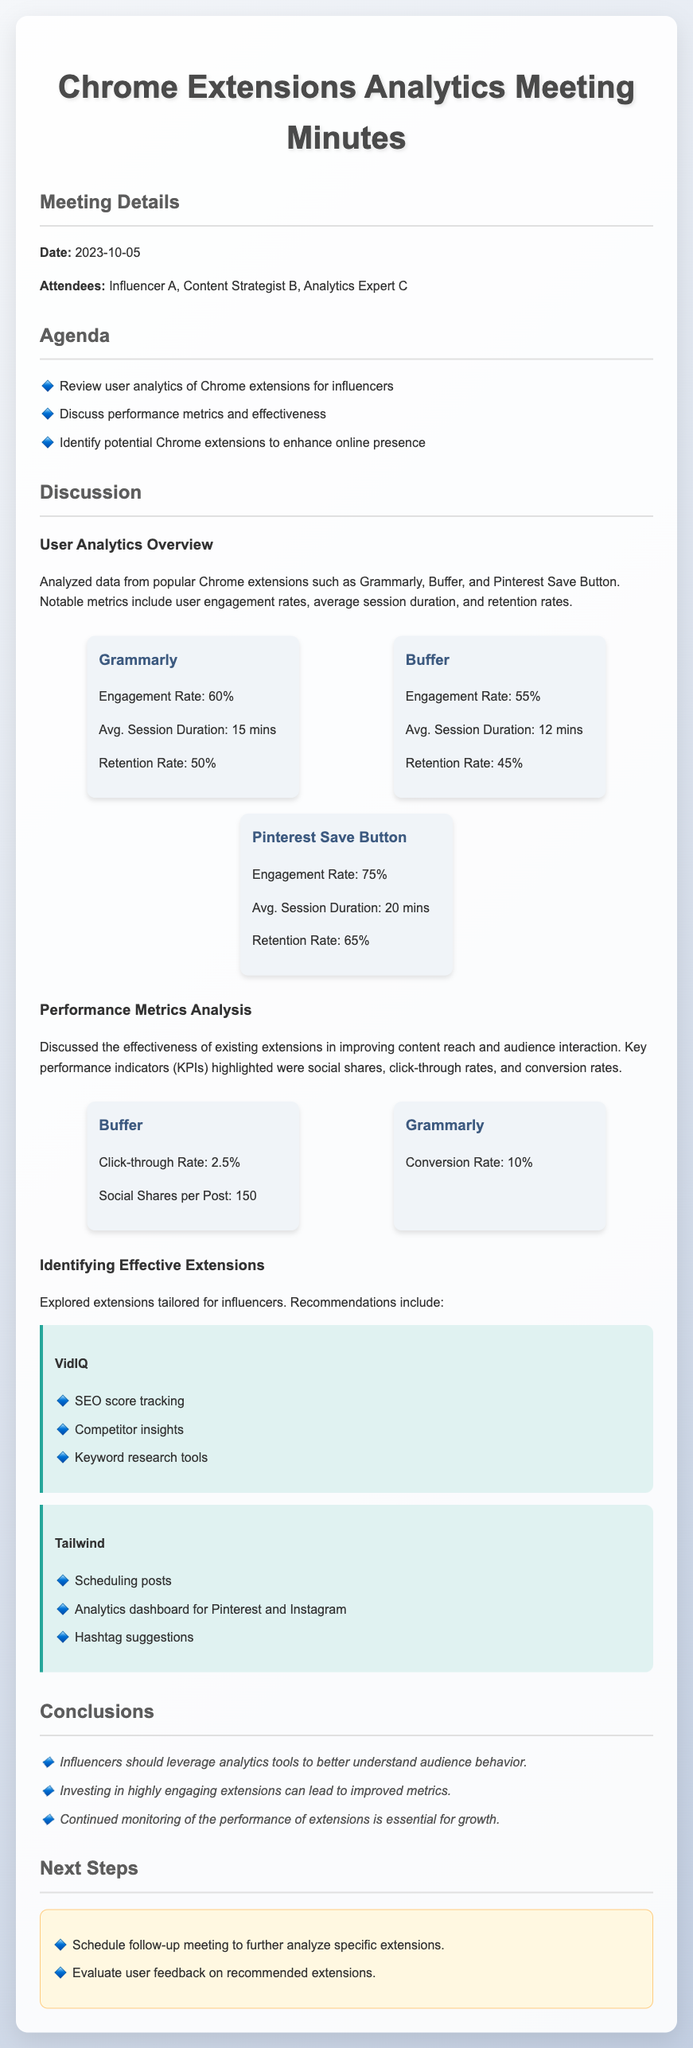what is the date of the meeting? The meeting date is explicitly stated in the document.
Answer: 2023-10-05 who attended the meeting? The document lists the attendees at the meeting.
Answer: Influencer A, Content Strategist B, Analytics Expert C which extension had the highest engagement rate? The document includes metrics for multiple extensions and specifies engagement rates for each.
Answer: Pinterest Save Button what is the average session duration for Grammarly? The average session duration for Grammarly is provided in the metrics section.
Answer: 15 mins what are the key performance indicators (KPIs) discussed in the meeting? The meeting minutes clearly outline the discussed KPIs related to performance metrics.
Answer: social shares, click-through rates, conversion rates what recommendations were made for Chrome extensions? The document lists recommendations for Chrome extensions tailored for influencers.
Answer: VidIQ, Tailwind how many social shares per post does Buffer have? The social shares per post for Buffer are explicitly mentioned in the performance metrics.
Answer: 150 what is the conversion rate for Grammarly? The conversion rate for Grammarly is provided in the metrics for performance analysis.
Answer: 10% what is the follow-up action proposed in the next steps? The document specifies actions to be taken after the meeting.
Answer: Schedule follow-up meeting to further analyze specific extensions 